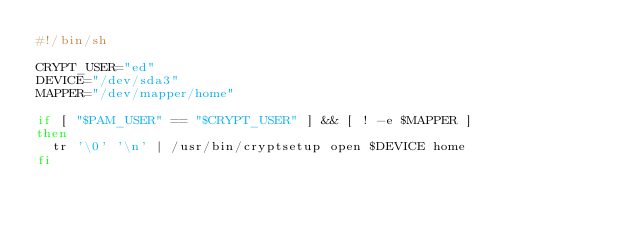Convert code to text. <code><loc_0><loc_0><loc_500><loc_500><_Bash_>#!/bin/sh

CRYPT_USER="ed"
DEVICE="/dev/sda3"
MAPPER="/dev/mapper/home"

if [ "$PAM_USER" == "$CRYPT_USER" ] && [ ! -e $MAPPER ]
then
  tr '\0' '\n' | /usr/bin/cryptsetup open $DEVICE home
fi
</code> 